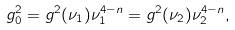Convert formula to latex. <formula><loc_0><loc_0><loc_500><loc_500>g _ { 0 } ^ { 2 } = g ^ { 2 } ( \nu _ { 1 } ) \nu _ { 1 } ^ { 4 - n } = g ^ { 2 } ( \nu _ { 2 } ) \nu _ { 2 } ^ { 4 - n } ,</formula> 